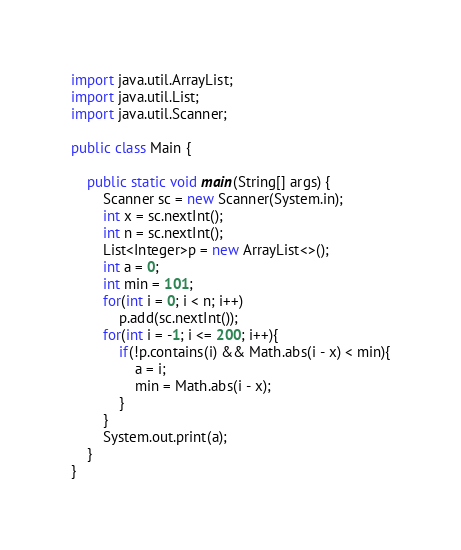Convert code to text. <code><loc_0><loc_0><loc_500><loc_500><_Java_>import java.util.ArrayList;
import java.util.List;
import java.util.Scanner;

public class Main {

	public static void main(String[] args) {
		Scanner sc = new Scanner(System.in);
		int x = sc.nextInt();
		int n = sc.nextInt();
		List<Integer>p = new ArrayList<>();
		int a = 0;
		int min = 101;
		for(int i = 0; i < n; i++)
			p.add(sc.nextInt());
		for(int i = -1; i <= 200; i++){
			if(!p.contains(i) && Math.abs(i - x) < min){
				a = i;
				min = Math.abs(i - x);
			}
		}
		System.out.print(a);
	}
}
</code> 